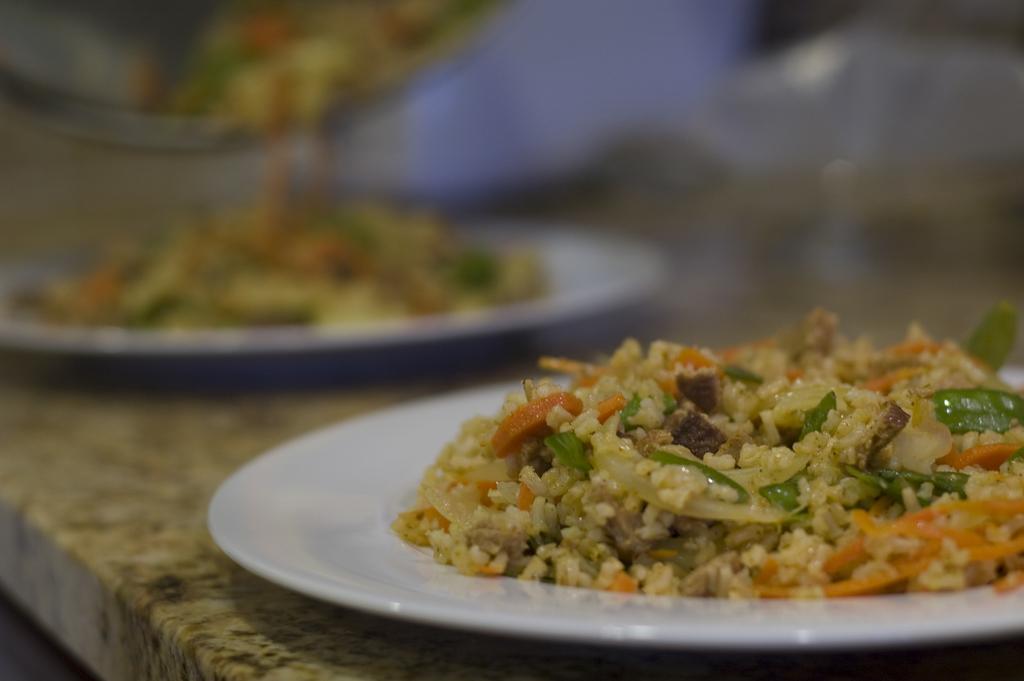In one or two sentences, can you explain what this image depicts? In this image I can see food items on white color plates. These plates is on a stone surface. The background of the image is blurred. 